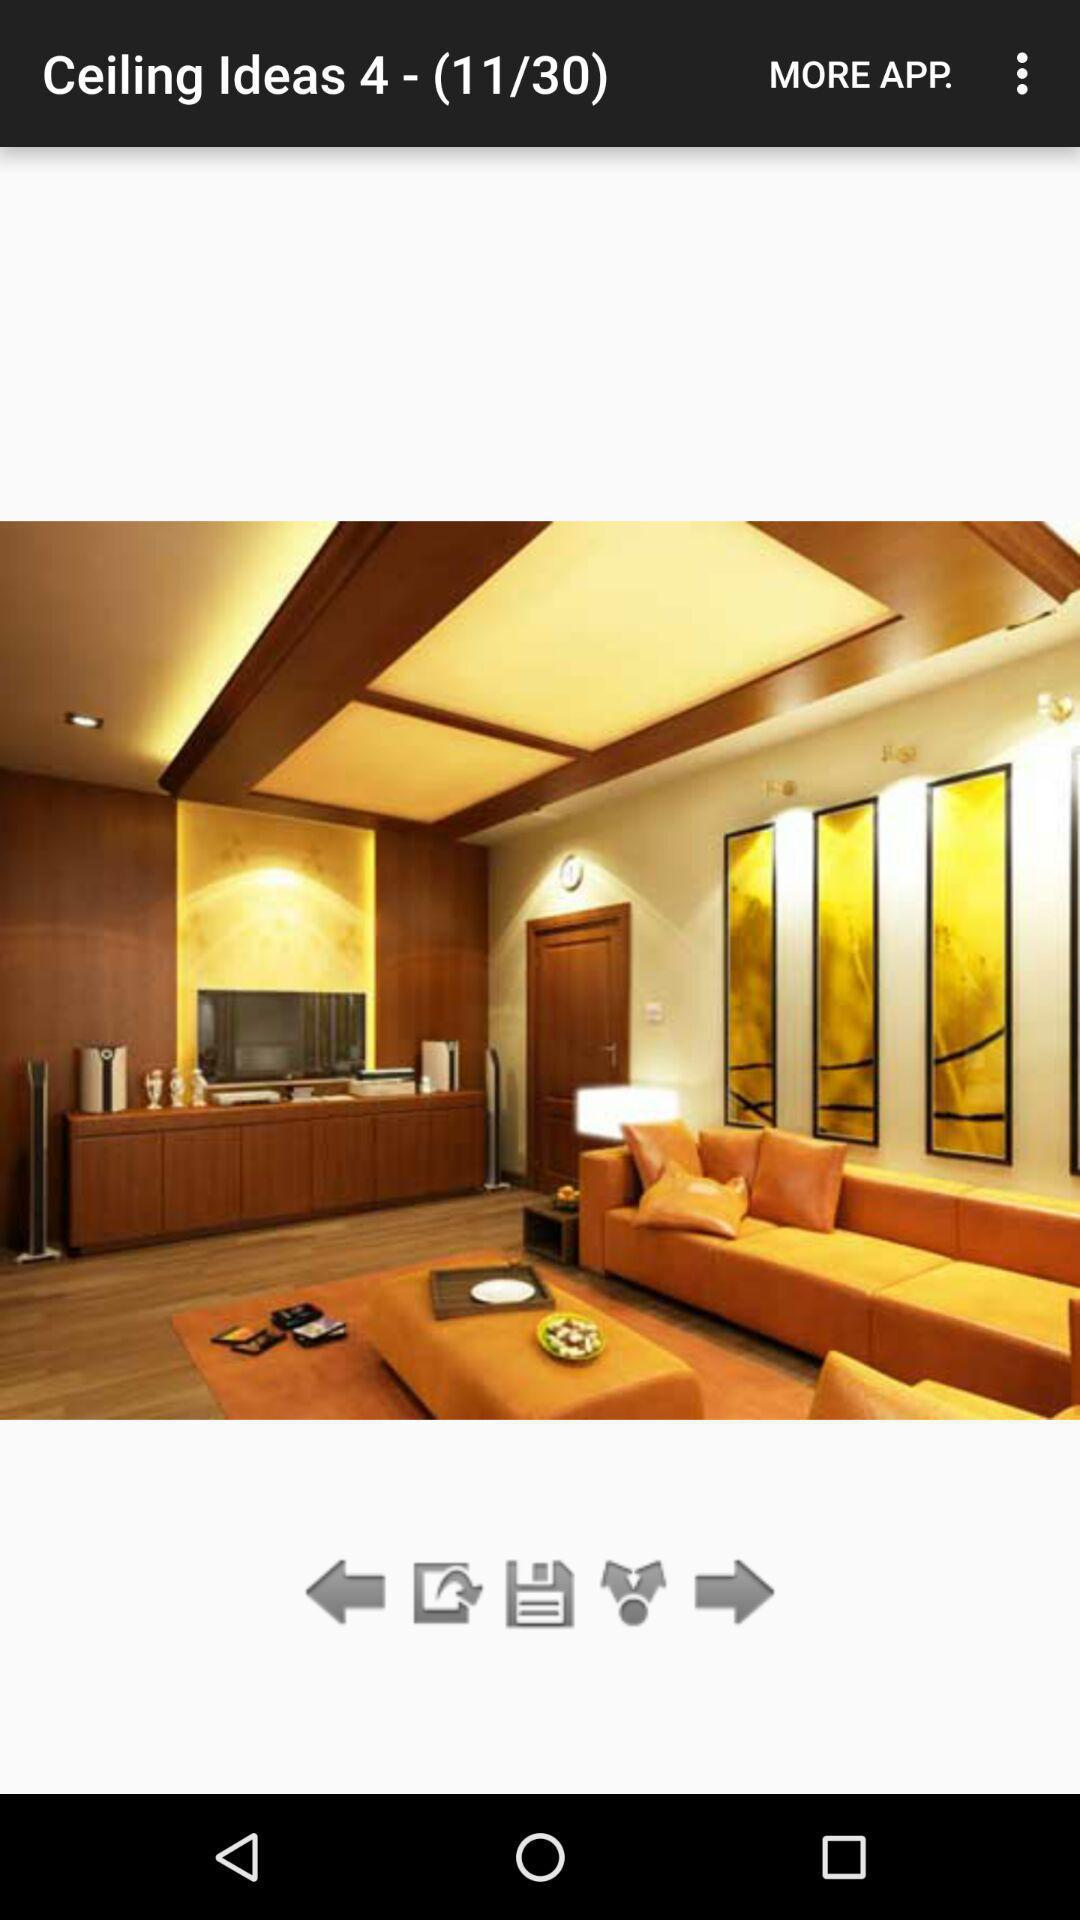What is the total number of images for "Ceiling Ideas 4" in the application? The total number of images for "Ceiling Ideas 4" is 30. 